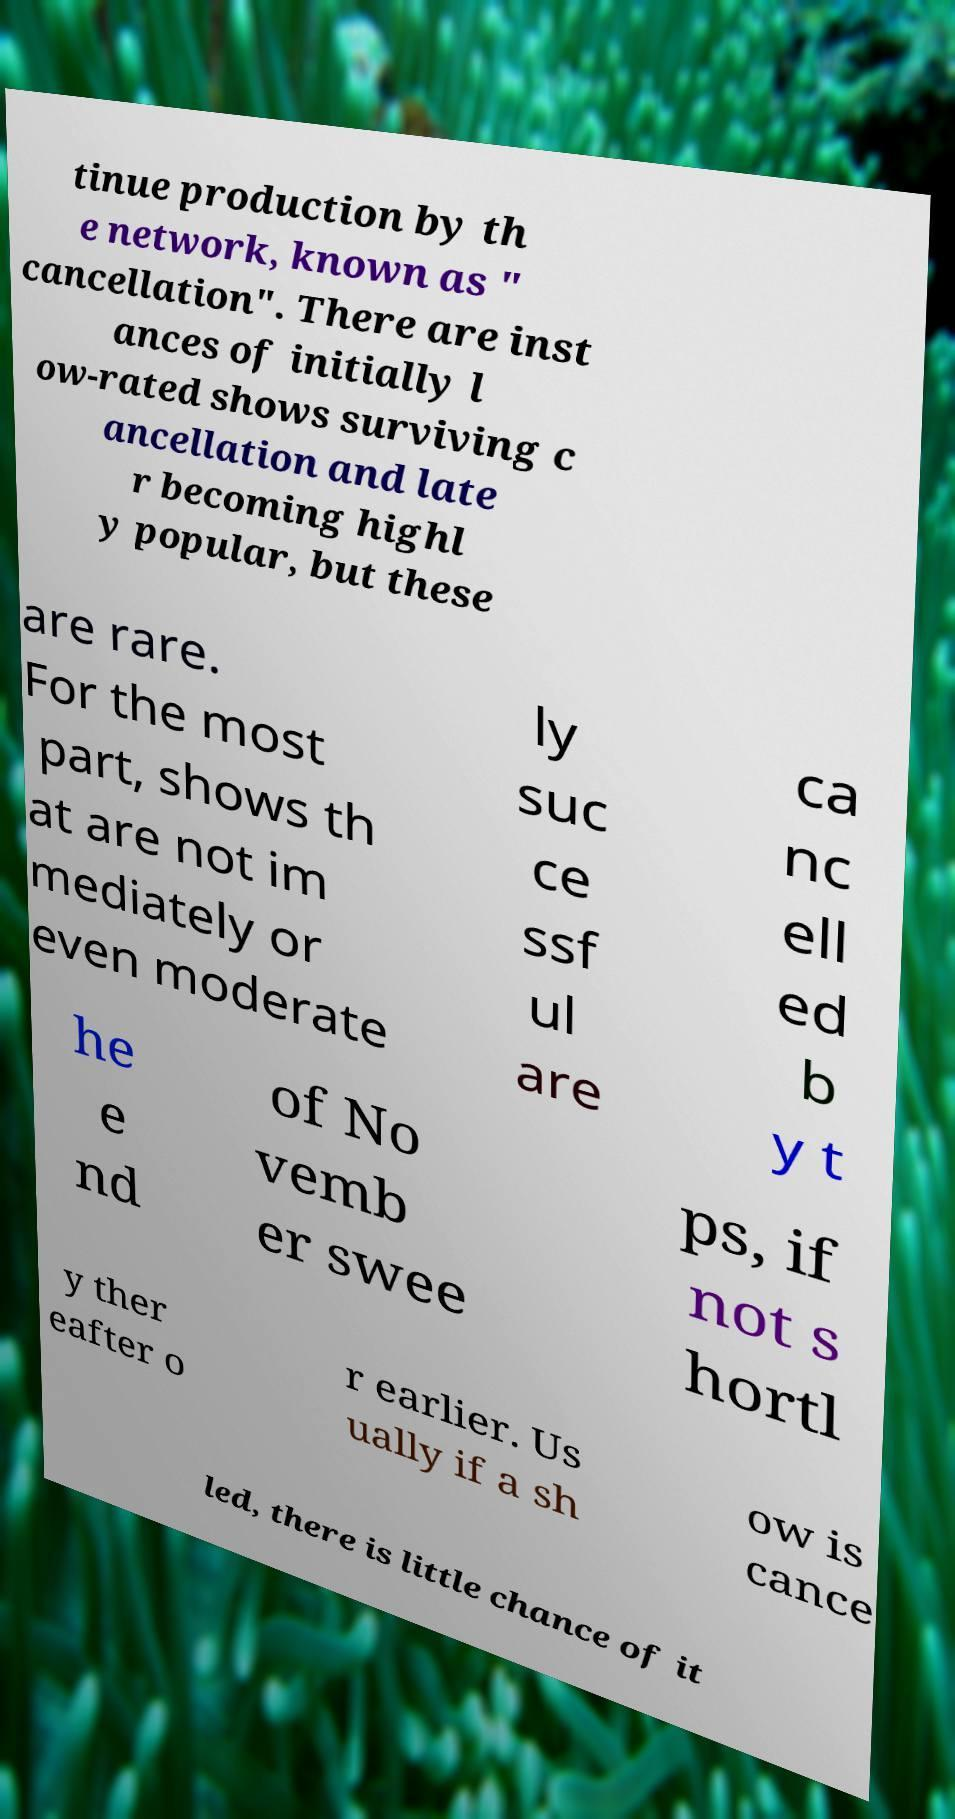Can you read and provide the text displayed in the image?This photo seems to have some interesting text. Can you extract and type it out for me? tinue production by th e network, known as " cancellation". There are inst ances of initially l ow-rated shows surviving c ancellation and late r becoming highl y popular, but these are rare. For the most part, shows th at are not im mediately or even moderate ly suc ce ssf ul are ca nc ell ed b y t he e nd of No vemb er swee ps, if not s hortl y ther eafter o r earlier. Us ually if a sh ow is cance led, there is little chance of it 